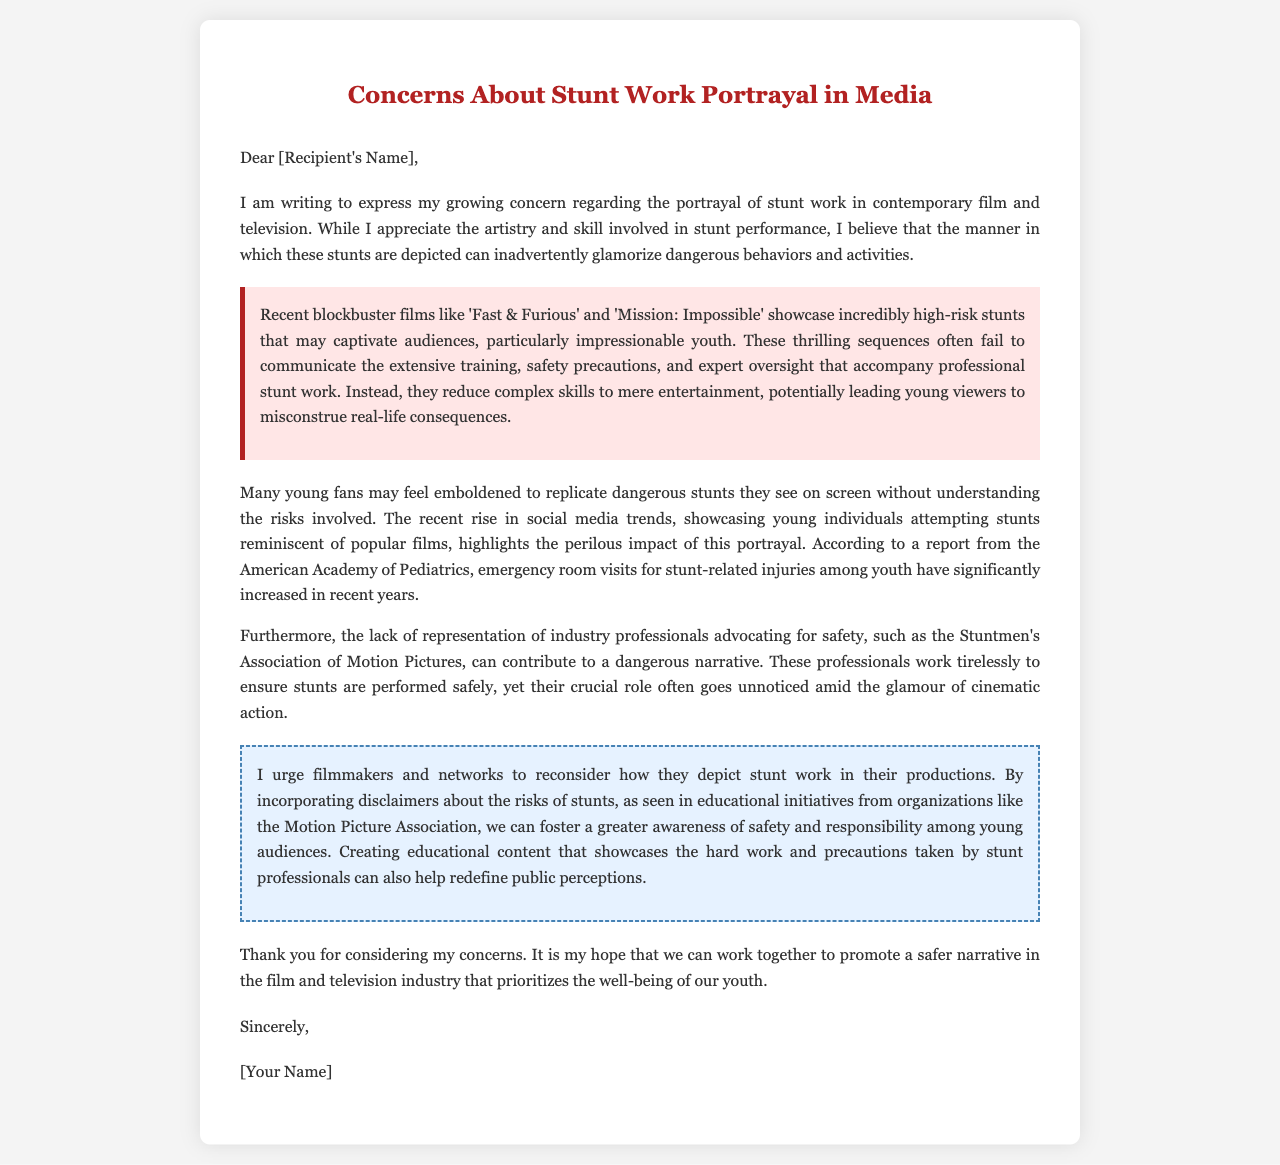What are the names of two movies mentioned? The letter specifically references two films that are examples of stunt work: 'Fast & Furious' and 'Mission: Impossible'.
Answer: 'Fast & Furious', 'Mission: Impossible' What organization is mentioned regarding safety advocacy? The letter talks about the Stuntmen's Association of Motion Pictures as professionals advocating for safety in stunt work.
Answer: Stuntmen's Association of Motion Pictures What has significantly increased among youth according to the American Academy of Pediatrics? The document states that emergency room visits for stunt-related injuries among youth have significantly increased in recent years.
Answer: Emergency room visits What does the letter urge filmmakers to reconsider? The letter advocates for filmmakers to reconsider how they depict stunt work in their productions, particularly regarding safety awareness.
Answer: Depicting stunt work What is the purpose of the educational initiatives mentioned? The letter suggests incorporating disclaimers about the risks of stunts to foster greater awareness of safety among young audiences.
Answer: Greater awareness of safety What kind of content does the letter suggest creating? The letter proposes creating educational content that showcases the hard work and precautions taken by stunt professionals.
Answer: Educational content What is the tone of the letter? The tone of the letter reflects a cautious and concerned attitude regarding the portrayal of stunt work in media.
Answer: Cautious and concerned What does the closing of the letter say? The closing of the letter includes a respectful farewell to the recipient.
Answer: Sincerely 